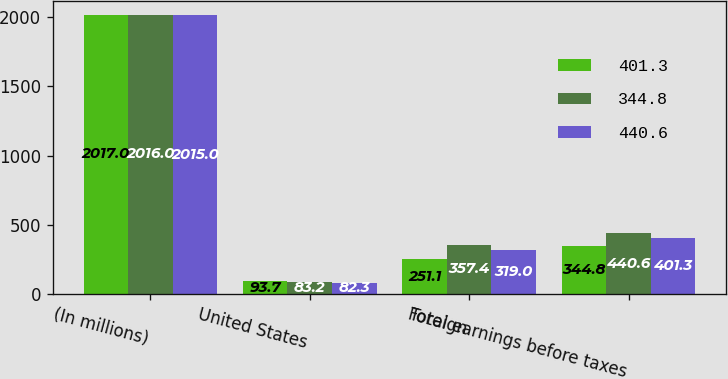Convert chart to OTSL. <chart><loc_0><loc_0><loc_500><loc_500><stacked_bar_chart><ecel><fcel>(In millions)<fcel>United States<fcel>Foreign<fcel>Total earnings before taxes<nl><fcel>401.3<fcel>2017<fcel>93.7<fcel>251.1<fcel>344.8<nl><fcel>344.8<fcel>2016<fcel>83.2<fcel>357.4<fcel>440.6<nl><fcel>440.6<fcel>2015<fcel>82.3<fcel>319<fcel>401.3<nl></chart> 